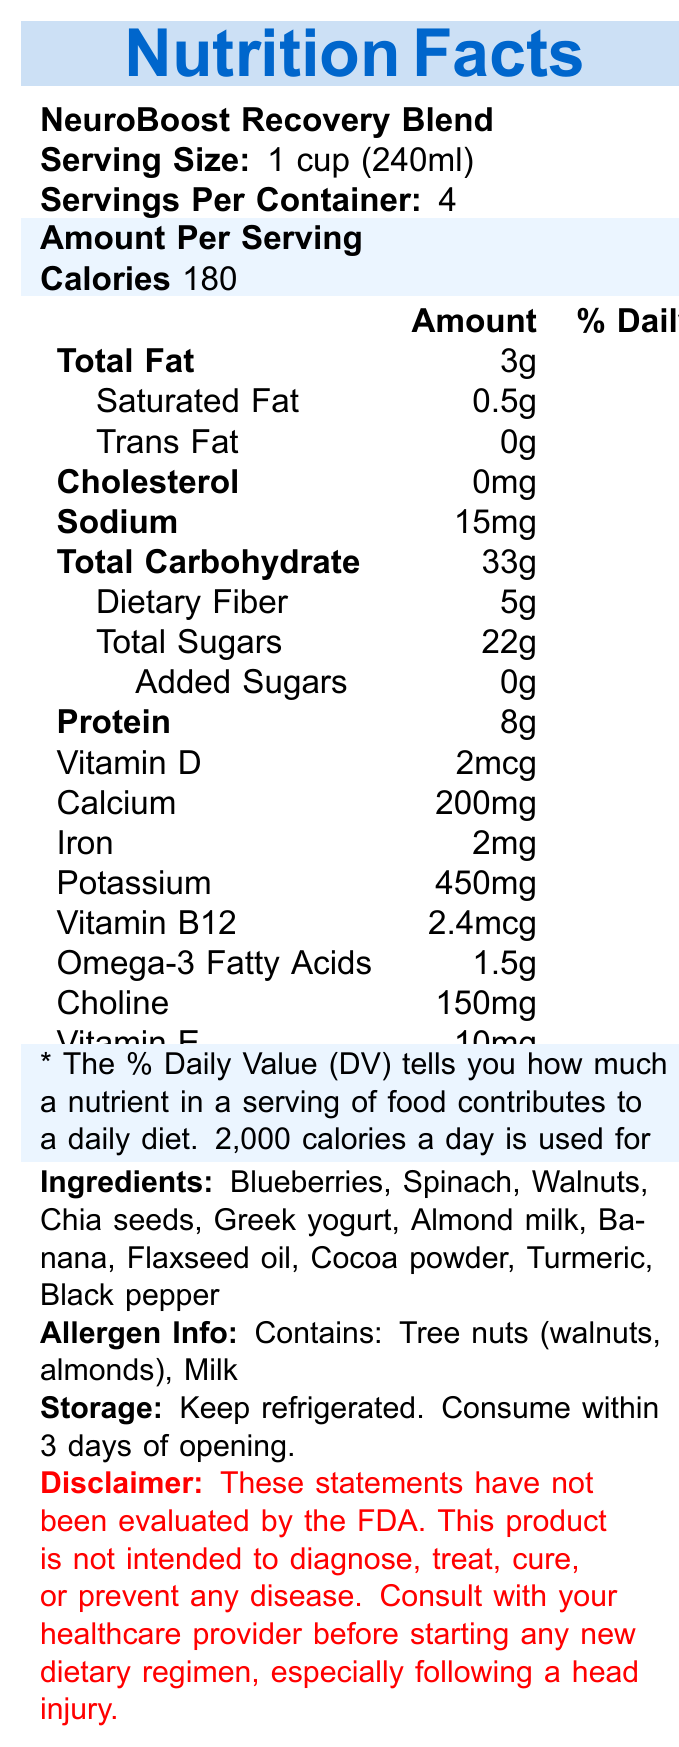what is the serving size? The document states that the serving size is 1 cup or 240ml.
Answer: 1 cup (240ml) how much sodium is there per serving? According to the document, each serving contains 15mg of sodium.
Answer: 15mg how many grams of protein do you get per serving? The document notes that there are 8 grams of protein per serving.
Answer: 8g is there any trans fat in the product? The document indicates that there is 0g of trans fat.
Answer: No what are the main ingredients in the NeuroBoost Recovery Blend? The ingredients list in the document includes these components.
Answer: Blueberries, Spinach, Walnuts, Chia seeds, Greek yogurt, Almond milk, Banana, Flaxseed oil, Cocoa powder, Turmeric, Black pepper how many calories are in one serving? The document states that each serving contains 180 calories.
Answer: 180 what percentage of daily value does Vitamin B12 provide? The document shows that Vitamin B12 provides 100% of the daily value.
Answer: 100% does this product contain cholesterol? The document states that the cholesterol content is 0mg, which is 0% of the daily value.
Answer: No what is the total carbohydrate content per serving? A. 30g B. 33g C. 35g D. 40g The document indicates that each serving contains 33g of total carbohydrates.
Answer: B. 33g which of the following nutrients is present in the greatest amount in terms of daily value percentage? A. Calcium B. Vitamin E C. Choline D. Magnesium Vitamin E presents 67% of the daily value, which is higher than the other options listed.
Answer: B. Vitamin E should you consult with a healthcare provider before starting this product following a head injury? The document includes a disclaimer that advises consulting with a healthcare provider before starting any new dietary regimen, especially following a head injury.
Answer: Yes what is the allergen information listed on the document? The allergen info section indicates that the product contains tree nuts and milk.
Answer: Contains: Tree nuts (walnuts, almonds), Milk how long should the product be consumed after opening? The storage information states to consume the product within 3 days of opening.
Answer: Within 3 days what is the main purpose of the NeuroBoost Recovery Blend? The health claim section explains that the product is designed to support cognitive function and recovery after a head injury.
Answer: To support cognitive function and recovery after head injury describe the entire document. The detailed document includes comprehensive nutritional information, ingredient lists, allergen warnings, and health-related warnings to inform the consumer.
Answer: The document is the Nutrition Facts Label for a product called NeuroBoost Recovery Blend. It details various nutritional components, including the serving size, servings per container, calories, fats, cholesterol, sodium, carbohydrates, dietary fiber, sugars, protein, and various vitamins and minerals. The label also lists the ingredients, allergens, storage instructions, and a disclaimer about consulting a healthcare provider before using the product, especially after a head injury. The health claim mentions support for cognitive function and brain health. what is the manufacturing date of the product? The document does not provide any information regarding the manufacturing date.
Answer: Cannot be determined 